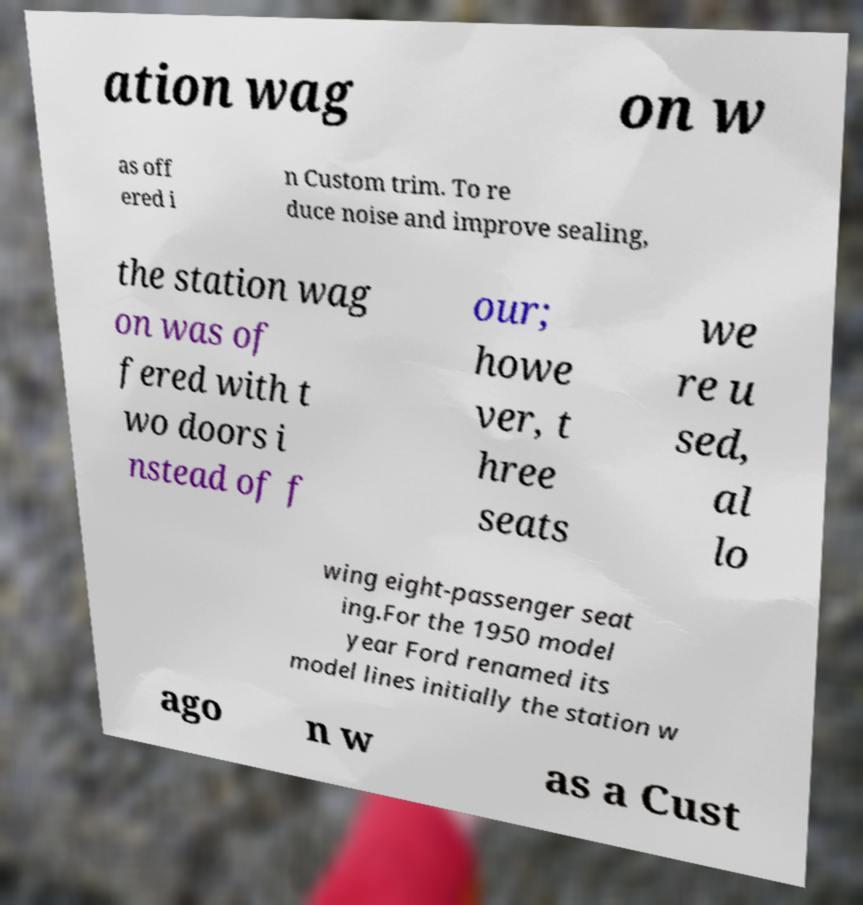I need the written content from this picture converted into text. Can you do that? ation wag on w as off ered i n Custom trim. To re duce noise and improve sealing, the station wag on was of fered with t wo doors i nstead of f our; howe ver, t hree seats we re u sed, al lo wing eight-passenger seat ing.For the 1950 model year Ford renamed its model lines initially the station w ago n w as a Cust 